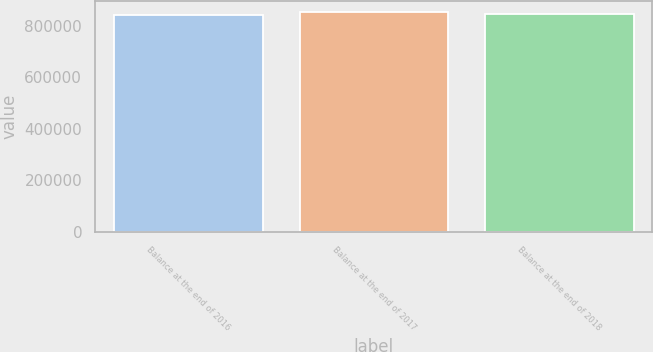<chart> <loc_0><loc_0><loc_500><loc_500><bar_chart><fcel>Balance at the end of 2016<fcel>Balance at the end of 2017<fcel>Balance at the end of 2018<nl><fcel>844200<fcel>853005<fcel>847544<nl></chart> 